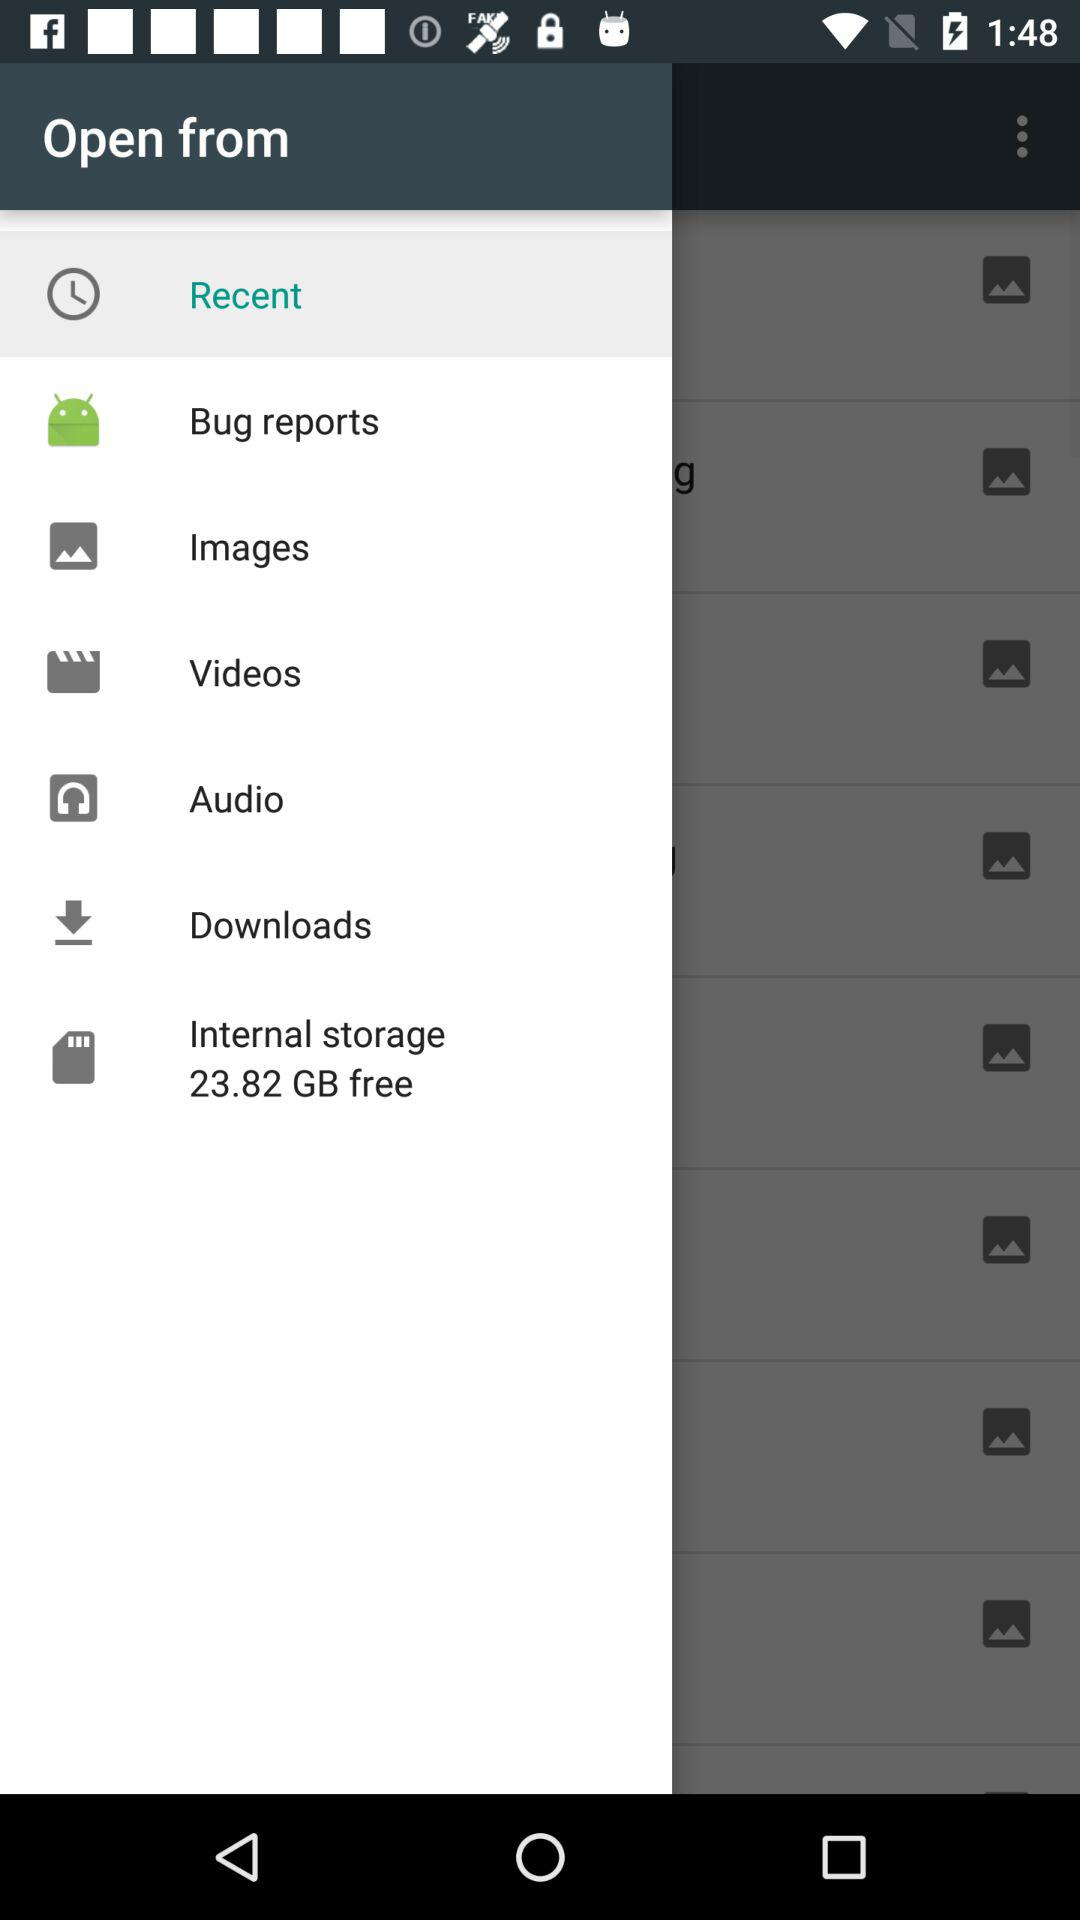Which is the selected item in the menu? The item that has been selected is "Recent". 